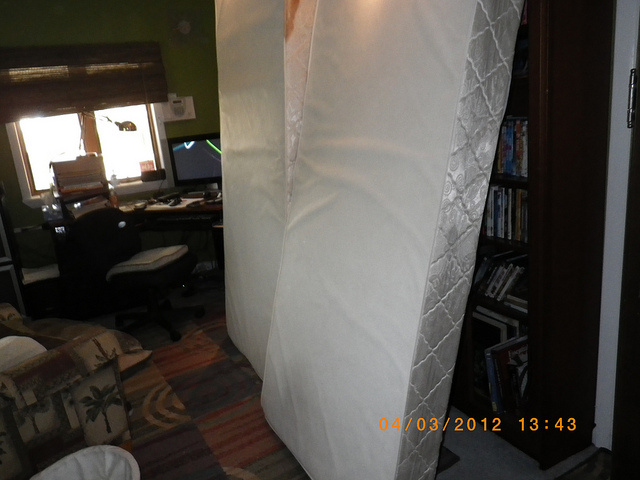Identify the text displayed in this image. 04/03/2012 13:43 